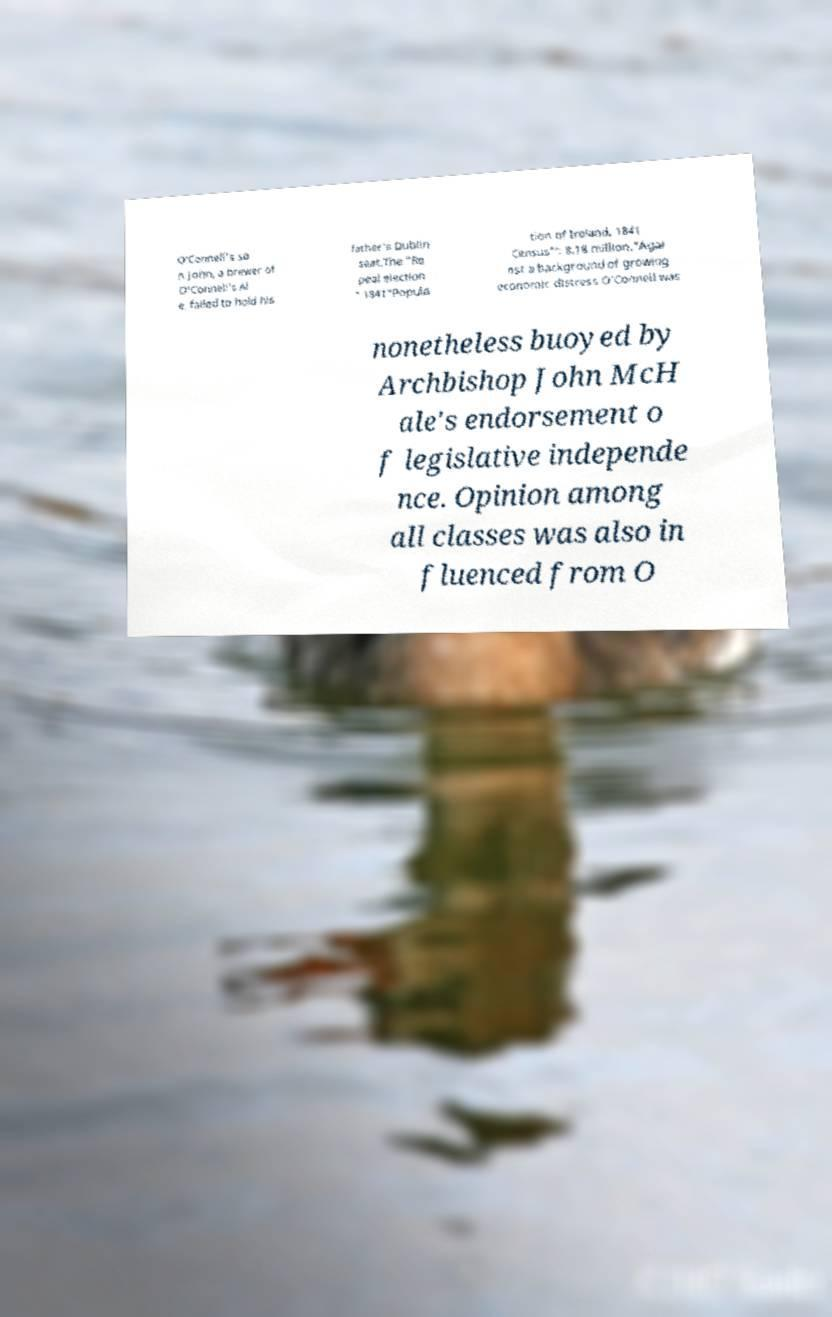I need the written content from this picture converted into text. Can you do that? O'Connell's so n John, a brewer of O'Connell's Al e, failed to hold his father's Dublin seat.The "Re peal election " 1841"Popula tion of Ireland, 1841 Census"': 8.18 million."Agai nst a background of growing economic distress O'Connell was nonetheless buoyed by Archbishop John McH ale's endorsement o f legislative independe nce. Opinion among all classes was also in fluenced from O 